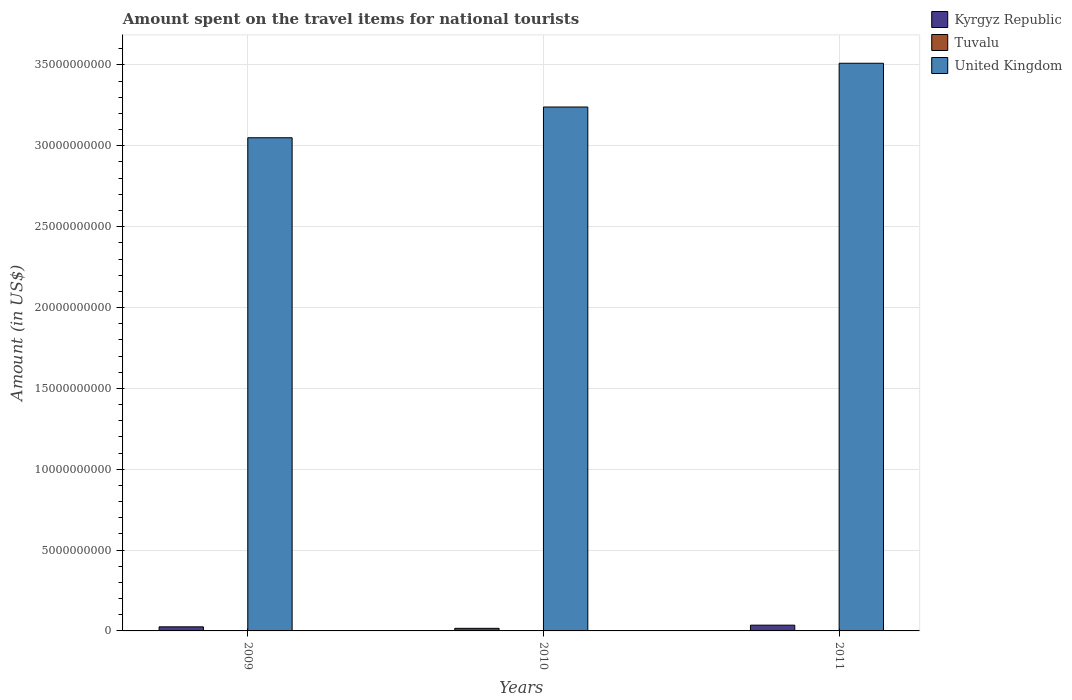How many different coloured bars are there?
Your answer should be very brief. 3. In how many cases, is the number of bars for a given year not equal to the number of legend labels?
Offer a very short reply. 0. What is the amount spent on the travel items for national tourists in Kyrgyz Republic in 2011?
Your response must be concise. 3.56e+08. Across all years, what is the maximum amount spent on the travel items for national tourists in Kyrgyz Republic?
Make the answer very short. 3.56e+08. Across all years, what is the minimum amount spent on the travel items for national tourists in Tuvalu?
Ensure brevity in your answer.  1.53e+06. In which year was the amount spent on the travel items for national tourists in Tuvalu maximum?
Keep it short and to the point. 2011. What is the total amount spent on the travel items for national tourists in Tuvalu in the graph?
Keep it short and to the point. 6.32e+06. What is the difference between the amount spent on the travel items for national tourists in United Kingdom in 2009 and that in 2011?
Offer a very short reply. -4.61e+09. What is the difference between the amount spent on the travel items for national tourists in Tuvalu in 2010 and the amount spent on the travel items for national tourists in Kyrgyz Republic in 2009?
Give a very brief answer. -2.51e+08. What is the average amount spent on the travel items for national tourists in United Kingdom per year?
Offer a terse response. 3.27e+1. In the year 2009, what is the difference between the amount spent on the travel items for national tourists in Kyrgyz Republic and amount spent on the travel items for national tourists in Tuvalu?
Make the answer very short. 2.51e+08. What is the ratio of the amount spent on the travel items for national tourists in United Kingdom in 2009 to that in 2011?
Make the answer very short. 0.87. Is the amount spent on the travel items for national tourists in Tuvalu in 2009 less than that in 2011?
Offer a terse response. Yes. What is the difference between the highest and the second highest amount spent on the travel items for national tourists in United Kingdom?
Give a very brief answer. 2.71e+09. What is the difference between the highest and the lowest amount spent on the travel items for national tourists in Tuvalu?
Ensure brevity in your answer.  9.10e+05. Is the sum of the amount spent on the travel items for national tourists in Kyrgyz Republic in 2009 and 2010 greater than the maximum amount spent on the travel items for national tourists in Tuvalu across all years?
Keep it short and to the point. Yes. What does the 1st bar from the left in 2010 represents?
Keep it short and to the point. Kyrgyz Republic. What does the 3rd bar from the right in 2009 represents?
Your response must be concise. Kyrgyz Republic. How many bars are there?
Your answer should be compact. 9. Are all the bars in the graph horizontal?
Your answer should be compact. No. What is the difference between two consecutive major ticks on the Y-axis?
Keep it short and to the point. 5.00e+09. Are the values on the major ticks of Y-axis written in scientific E-notation?
Give a very brief answer. No. Does the graph contain grids?
Your response must be concise. Yes. What is the title of the graph?
Offer a very short reply. Amount spent on the travel items for national tourists. Does "Sri Lanka" appear as one of the legend labels in the graph?
Offer a very short reply. No. What is the label or title of the X-axis?
Your response must be concise. Years. What is the Amount (in US$) of Kyrgyz Republic in 2009?
Offer a very short reply. 2.53e+08. What is the Amount (in US$) of Tuvalu in 2009?
Offer a terse response. 1.53e+06. What is the Amount (in US$) in United Kingdom in 2009?
Your answer should be compact. 3.05e+1. What is the Amount (in US$) in Kyrgyz Republic in 2010?
Give a very brief answer. 1.60e+08. What is the Amount (in US$) in Tuvalu in 2010?
Your response must be concise. 2.35e+06. What is the Amount (in US$) in United Kingdom in 2010?
Ensure brevity in your answer.  3.24e+1. What is the Amount (in US$) in Kyrgyz Republic in 2011?
Give a very brief answer. 3.56e+08. What is the Amount (in US$) in Tuvalu in 2011?
Provide a succinct answer. 2.44e+06. What is the Amount (in US$) in United Kingdom in 2011?
Give a very brief answer. 3.51e+1. Across all years, what is the maximum Amount (in US$) in Kyrgyz Republic?
Your answer should be compact. 3.56e+08. Across all years, what is the maximum Amount (in US$) of Tuvalu?
Ensure brevity in your answer.  2.44e+06. Across all years, what is the maximum Amount (in US$) of United Kingdom?
Provide a succinct answer. 3.51e+1. Across all years, what is the minimum Amount (in US$) in Kyrgyz Republic?
Make the answer very short. 1.60e+08. Across all years, what is the minimum Amount (in US$) in Tuvalu?
Your answer should be compact. 1.53e+06. Across all years, what is the minimum Amount (in US$) in United Kingdom?
Provide a succinct answer. 3.05e+1. What is the total Amount (in US$) of Kyrgyz Republic in the graph?
Ensure brevity in your answer.  7.69e+08. What is the total Amount (in US$) of Tuvalu in the graph?
Keep it short and to the point. 6.32e+06. What is the total Amount (in US$) in United Kingdom in the graph?
Ensure brevity in your answer.  9.80e+1. What is the difference between the Amount (in US$) of Kyrgyz Republic in 2009 and that in 2010?
Your answer should be compact. 9.30e+07. What is the difference between the Amount (in US$) in Tuvalu in 2009 and that in 2010?
Provide a succinct answer. -8.20e+05. What is the difference between the Amount (in US$) in United Kingdom in 2009 and that in 2010?
Your answer should be compact. -1.90e+09. What is the difference between the Amount (in US$) of Kyrgyz Republic in 2009 and that in 2011?
Provide a short and direct response. -1.03e+08. What is the difference between the Amount (in US$) of Tuvalu in 2009 and that in 2011?
Provide a short and direct response. -9.10e+05. What is the difference between the Amount (in US$) in United Kingdom in 2009 and that in 2011?
Give a very brief answer. -4.61e+09. What is the difference between the Amount (in US$) of Kyrgyz Republic in 2010 and that in 2011?
Make the answer very short. -1.96e+08. What is the difference between the Amount (in US$) of Tuvalu in 2010 and that in 2011?
Offer a terse response. -9.00e+04. What is the difference between the Amount (in US$) in United Kingdom in 2010 and that in 2011?
Make the answer very short. -2.71e+09. What is the difference between the Amount (in US$) in Kyrgyz Republic in 2009 and the Amount (in US$) in Tuvalu in 2010?
Your answer should be compact. 2.51e+08. What is the difference between the Amount (in US$) in Kyrgyz Republic in 2009 and the Amount (in US$) in United Kingdom in 2010?
Your response must be concise. -3.21e+1. What is the difference between the Amount (in US$) in Tuvalu in 2009 and the Amount (in US$) in United Kingdom in 2010?
Provide a short and direct response. -3.24e+1. What is the difference between the Amount (in US$) in Kyrgyz Republic in 2009 and the Amount (in US$) in Tuvalu in 2011?
Give a very brief answer. 2.51e+08. What is the difference between the Amount (in US$) in Kyrgyz Republic in 2009 and the Amount (in US$) in United Kingdom in 2011?
Your answer should be compact. -3.49e+1. What is the difference between the Amount (in US$) of Tuvalu in 2009 and the Amount (in US$) of United Kingdom in 2011?
Your answer should be compact. -3.51e+1. What is the difference between the Amount (in US$) in Kyrgyz Republic in 2010 and the Amount (in US$) in Tuvalu in 2011?
Keep it short and to the point. 1.58e+08. What is the difference between the Amount (in US$) in Kyrgyz Republic in 2010 and the Amount (in US$) in United Kingdom in 2011?
Your answer should be compact. -3.49e+1. What is the difference between the Amount (in US$) in Tuvalu in 2010 and the Amount (in US$) in United Kingdom in 2011?
Offer a very short reply. -3.51e+1. What is the average Amount (in US$) of Kyrgyz Republic per year?
Ensure brevity in your answer.  2.56e+08. What is the average Amount (in US$) of Tuvalu per year?
Your response must be concise. 2.11e+06. What is the average Amount (in US$) of United Kingdom per year?
Give a very brief answer. 3.27e+1. In the year 2009, what is the difference between the Amount (in US$) in Kyrgyz Republic and Amount (in US$) in Tuvalu?
Keep it short and to the point. 2.51e+08. In the year 2009, what is the difference between the Amount (in US$) in Kyrgyz Republic and Amount (in US$) in United Kingdom?
Your answer should be very brief. -3.02e+1. In the year 2009, what is the difference between the Amount (in US$) of Tuvalu and Amount (in US$) of United Kingdom?
Your response must be concise. -3.05e+1. In the year 2010, what is the difference between the Amount (in US$) of Kyrgyz Republic and Amount (in US$) of Tuvalu?
Provide a short and direct response. 1.58e+08. In the year 2010, what is the difference between the Amount (in US$) in Kyrgyz Republic and Amount (in US$) in United Kingdom?
Your response must be concise. -3.22e+1. In the year 2010, what is the difference between the Amount (in US$) in Tuvalu and Amount (in US$) in United Kingdom?
Offer a very short reply. -3.24e+1. In the year 2011, what is the difference between the Amount (in US$) in Kyrgyz Republic and Amount (in US$) in Tuvalu?
Your answer should be very brief. 3.54e+08. In the year 2011, what is the difference between the Amount (in US$) of Kyrgyz Republic and Amount (in US$) of United Kingdom?
Your answer should be compact. -3.47e+1. In the year 2011, what is the difference between the Amount (in US$) in Tuvalu and Amount (in US$) in United Kingdom?
Offer a very short reply. -3.51e+1. What is the ratio of the Amount (in US$) in Kyrgyz Republic in 2009 to that in 2010?
Make the answer very short. 1.58. What is the ratio of the Amount (in US$) in Tuvalu in 2009 to that in 2010?
Your answer should be compact. 0.65. What is the ratio of the Amount (in US$) of United Kingdom in 2009 to that in 2010?
Offer a terse response. 0.94. What is the ratio of the Amount (in US$) of Kyrgyz Republic in 2009 to that in 2011?
Offer a very short reply. 0.71. What is the ratio of the Amount (in US$) in Tuvalu in 2009 to that in 2011?
Make the answer very short. 0.63. What is the ratio of the Amount (in US$) in United Kingdom in 2009 to that in 2011?
Give a very brief answer. 0.87. What is the ratio of the Amount (in US$) in Kyrgyz Republic in 2010 to that in 2011?
Provide a succinct answer. 0.45. What is the ratio of the Amount (in US$) of Tuvalu in 2010 to that in 2011?
Keep it short and to the point. 0.96. What is the ratio of the Amount (in US$) in United Kingdom in 2010 to that in 2011?
Keep it short and to the point. 0.92. What is the difference between the highest and the second highest Amount (in US$) in Kyrgyz Republic?
Your response must be concise. 1.03e+08. What is the difference between the highest and the second highest Amount (in US$) of Tuvalu?
Your answer should be very brief. 9.00e+04. What is the difference between the highest and the second highest Amount (in US$) in United Kingdom?
Your answer should be very brief. 2.71e+09. What is the difference between the highest and the lowest Amount (in US$) in Kyrgyz Republic?
Offer a terse response. 1.96e+08. What is the difference between the highest and the lowest Amount (in US$) of Tuvalu?
Your response must be concise. 9.10e+05. What is the difference between the highest and the lowest Amount (in US$) of United Kingdom?
Give a very brief answer. 4.61e+09. 